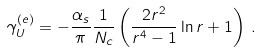Convert formula to latex. <formula><loc_0><loc_0><loc_500><loc_500>\gamma ^ { ( e ) } _ { U } = - \frac { \alpha _ { s } } { \pi } \frac { 1 } { N _ { c } } \left ( \frac { 2 r ^ { 2 } } { r ^ { 4 } - 1 } \ln r + 1 \right ) \, .</formula> 